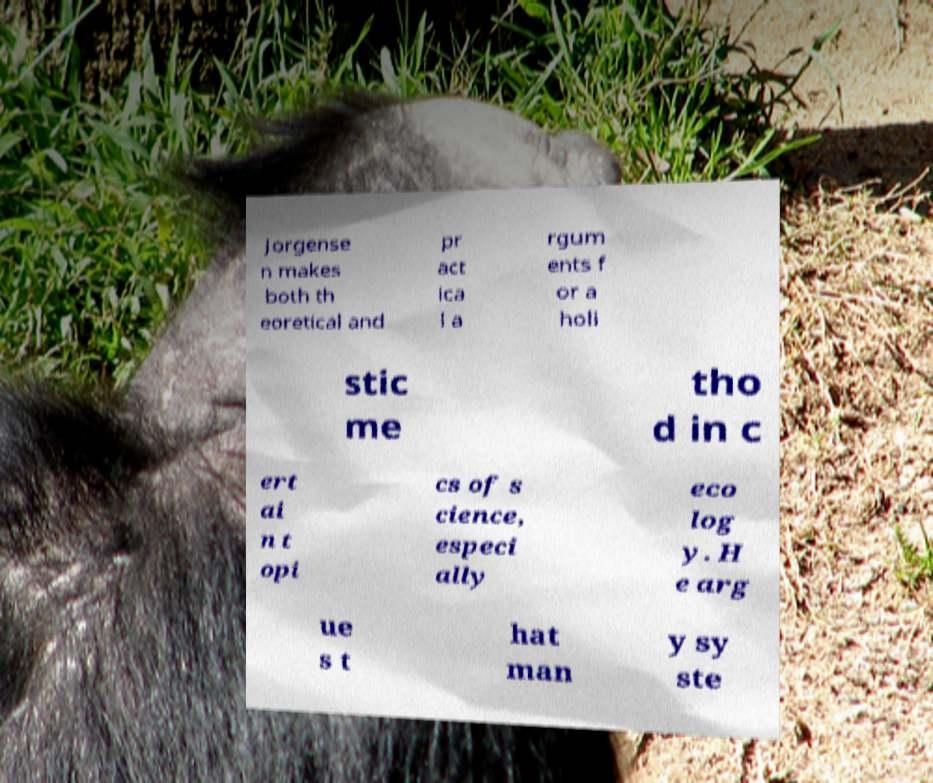I need the written content from this picture converted into text. Can you do that? Jorgense n makes both th eoretical and pr act ica l a rgum ents f or a holi stic me tho d in c ert ai n t opi cs of s cience, especi ally eco log y. H e arg ue s t hat man y sy ste 